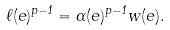<formula> <loc_0><loc_0><loc_500><loc_500>\ell ( e ) ^ { p - 1 } = \alpha ( e ) ^ { p - 1 } w ( e ) .</formula> 